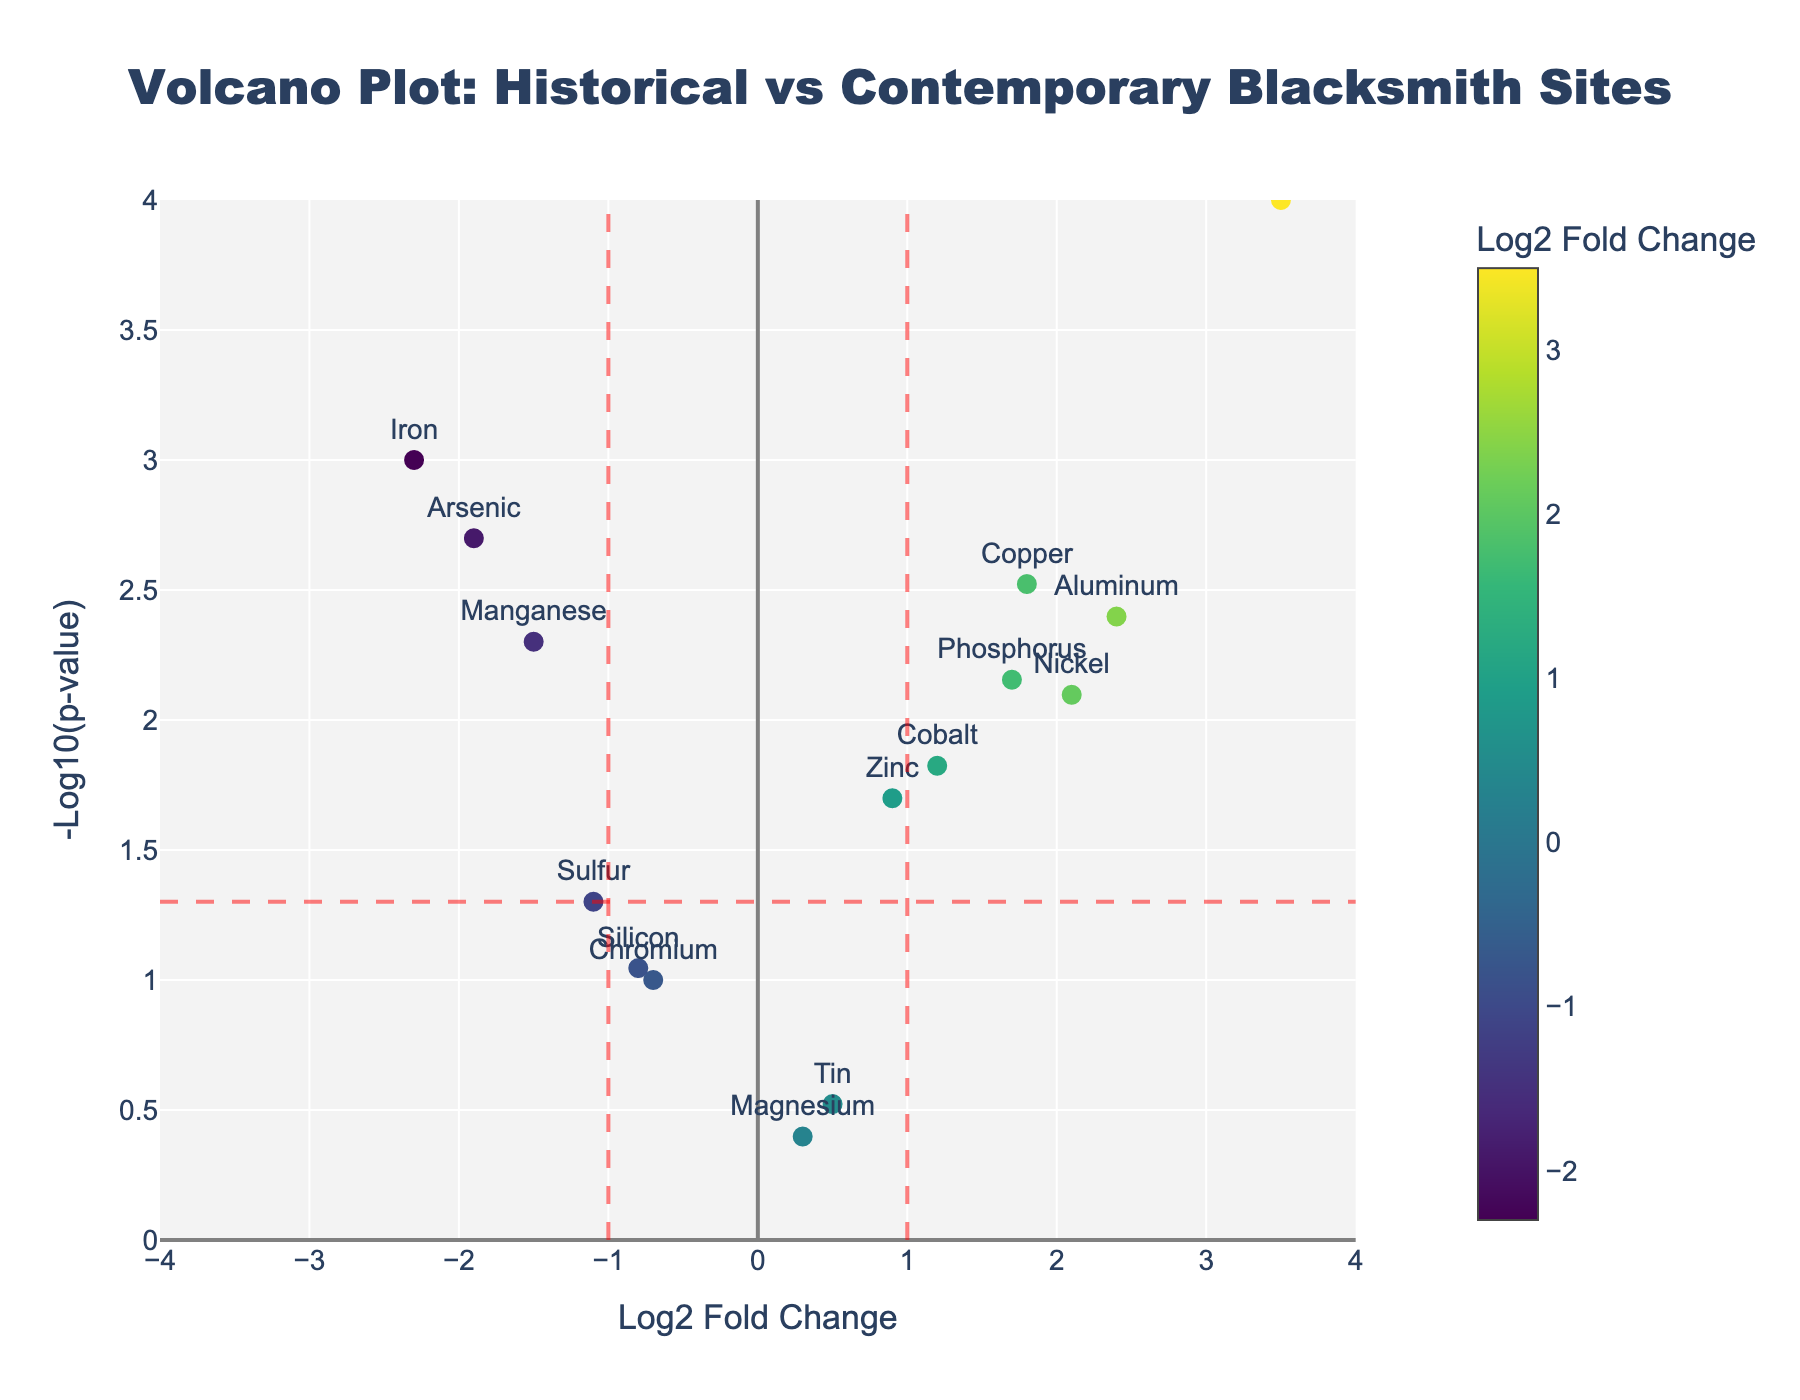What is the title of the figure? The title is usually displayed at the top of the figure. In this case, the title is "Volcano Plot: Historical vs Contemporary Blacksmith Sites."
Answer: Volcano Plot: Historical vs Contemporary Blacksmith Sites What does the x-axis represent? The x-axis typically indicates Log2 Fold Change in a volcano plot, showing how much the concentration of each element changes between historical and contemporary blacksmith sites.
Answer: Log2 Fold Change What does the y-axis represent? The y-axis generally represents -Log10(p-value) in a volcano plot, indicating the significance of the changes in element concentrations.
Answer: -Log10(p-value) Which element has the highest Log2 Fold Change? By looking at the x-axis and finding the data point that is furthest to the right, we can identify that Lead has the highest Log2 Fold Change.
Answer: Lead Which element has the lowest p-value? The p-value is represented by the height (y-axis) on the plot. The element with the highest y-value has the lowest p-value. In this case, Lead has the lowest p-value.
Answer: Lead Are there any elements with a negative Log2 Fold Change below -1 that are statistically significant (p-value < 0.05)? Elements with significant negative Log2 Fold Change appear on the left side of the plot under the dashed vertical red line at x = -1 and above the horizontal red line at y = 1.301 (p-value=0.05). Iron, Arsenic, and Manganese meet these criteria.
Answer: Iron, Arsenic, Manganese How many elements have a Log2 Fold Change greater than 1 and are statistically significant (p-value < 0.05)? By looking to the right of the vertical red line at x = 1 and above the horizontal red line at y = 1.301, we count Copper, Nickel, Cobalt, Phosphorus, Aluminum, and Lead. This makes a total of six elements.
Answer: 6 Which element has a Log2 Fold Change closest to zero but is still statistically significant (p-value < 0.05)? We need to identify the element closest to the center (x=0) while being above the horizontal red line (y = 1.301). Zinc has a Log2 Fold Change of 0.9 which is closest to zero.
Answer: Zinc Is there any element with a negative Log2 Fold Change but not statistically significant (p-value ≥ 0.05)? Elements to the left of x=0 and below the horizontal red line (y=1.301) are not significant. Chromium and Silicon meet these criteria.
Answer: Chromium, Silicon 